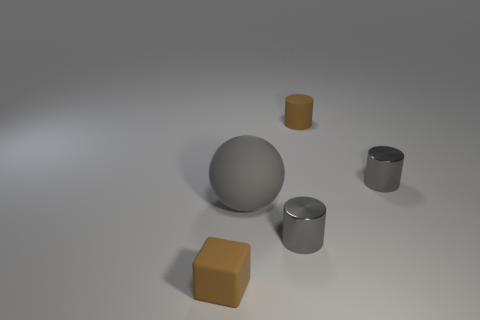There is a object that is in front of the brown rubber cylinder and behind the big gray sphere; what color is it?
Keep it short and to the point. Gray. How many gray cylinders have the same size as the brown rubber block?
Offer a terse response. 2. There is a small matte thing left of the tiny brown rubber thing that is on the right side of the tiny block; what is its shape?
Make the answer very short. Cube. The tiny matte object that is in front of the metal cylinder that is to the right of the tiny gray object that is in front of the ball is what shape?
Your response must be concise. Cube. How many other gray objects are the same shape as the large rubber thing?
Ensure brevity in your answer.  0. How many gray spheres are behind the tiny metal thing that is to the right of the small brown rubber cylinder?
Provide a short and direct response. 0. What number of matte things are tiny cyan cylinders or small cylinders?
Ensure brevity in your answer.  1. Is there a brown cube made of the same material as the gray ball?
Provide a succinct answer. Yes. What number of objects are things right of the brown cube or things behind the big sphere?
Provide a succinct answer. 4. There is a tiny shiny object that is behind the big rubber thing; is it the same color as the small matte cylinder?
Make the answer very short. No. 